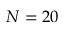Convert formula to latex. <formula><loc_0><loc_0><loc_500><loc_500>N = 2 0</formula> 